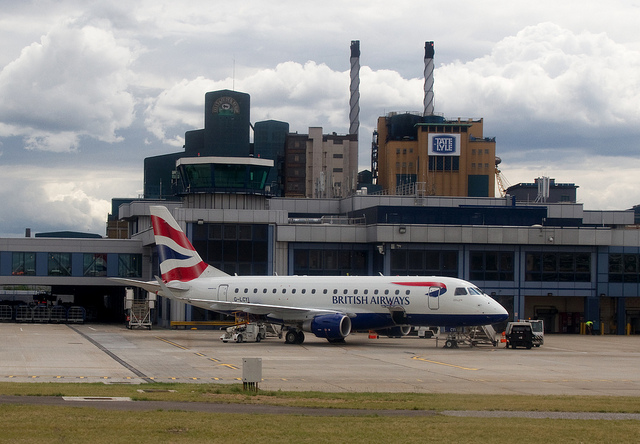What type of aircraft is shown in the foreground? The aircraft in the foreground is a British Airways Embraer E190, a short-haul regional jet. 